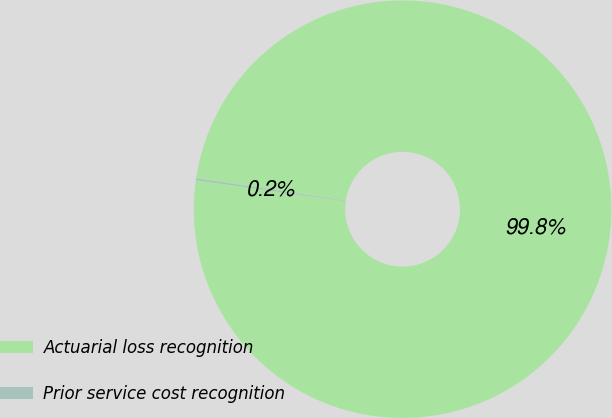<chart> <loc_0><loc_0><loc_500><loc_500><pie_chart><fcel>Actuarial loss recognition<fcel>Prior service cost recognition<nl><fcel>99.85%<fcel>0.15%<nl></chart> 